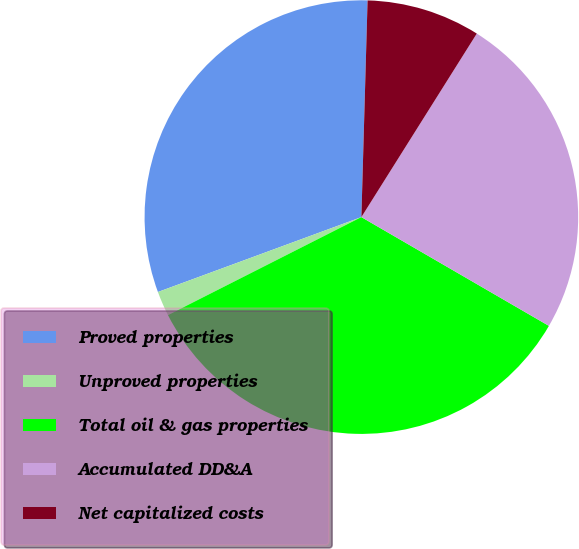Convert chart. <chart><loc_0><loc_0><loc_500><loc_500><pie_chart><fcel>Proved properties<fcel>Unproved properties<fcel>Total oil & gas properties<fcel>Accumulated DD&A<fcel>Net capitalized costs<nl><fcel>31.07%<fcel>1.85%<fcel>34.17%<fcel>24.43%<fcel>8.48%<nl></chart> 